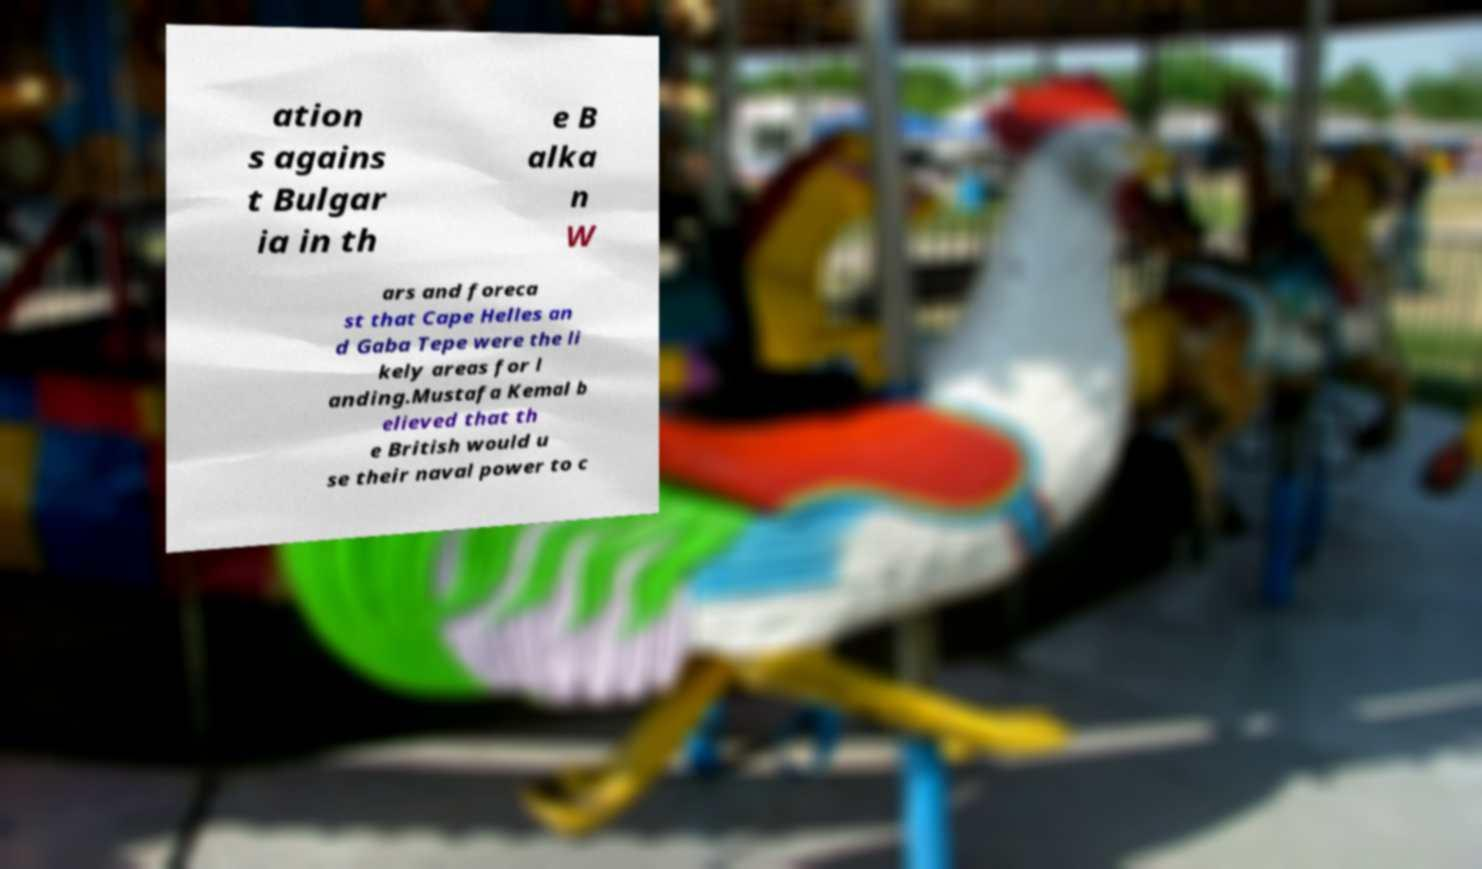What messages or text are displayed in this image? I need them in a readable, typed format. ation s agains t Bulgar ia in th e B alka n W ars and foreca st that Cape Helles an d Gaba Tepe were the li kely areas for l anding.Mustafa Kemal b elieved that th e British would u se their naval power to c 